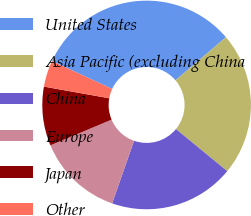Convert chart to OTSL. <chart><loc_0><loc_0><loc_500><loc_500><pie_chart><fcel>United States<fcel>Asia Pacific (excluding China<fcel>China<fcel>Europe<fcel>Japan<fcel>Other<nl><fcel>31.85%<fcel>22.19%<fcel>19.42%<fcel>13.31%<fcel>9.14%<fcel>4.09%<nl></chart> 